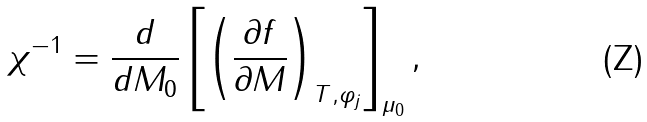<formula> <loc_0><loc_0><loc_500><loc_500>\chi ^ { - 1 } = \frac { d } { d M _ { 0 } } \left [ \left ( \frac { \partial f } { \partial M } \right ) _ { T , \varphi _ { j } } \right ] _ { \mu _ { 0 } } ,</formula> 